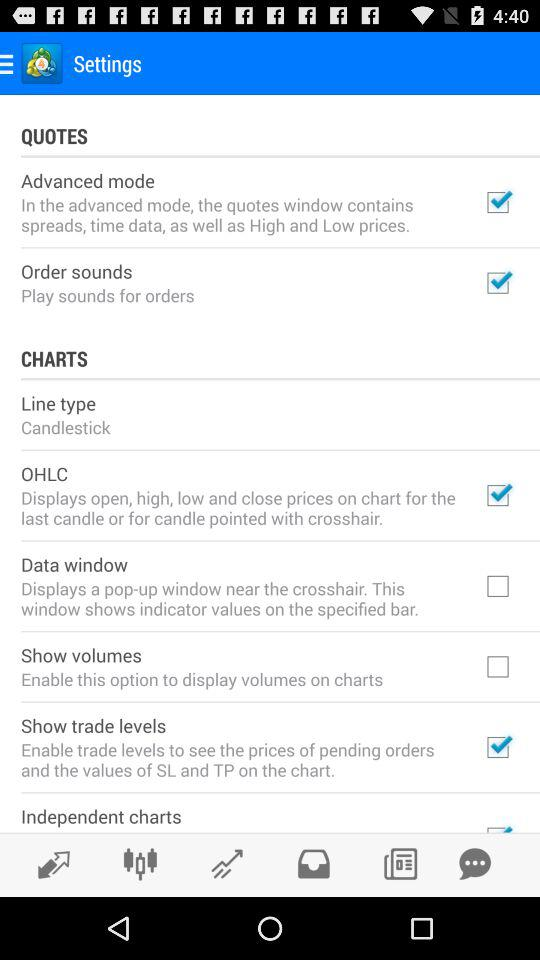How many checkboxes are in the quotes section?
Answer the question using a single word or phrase. 2 